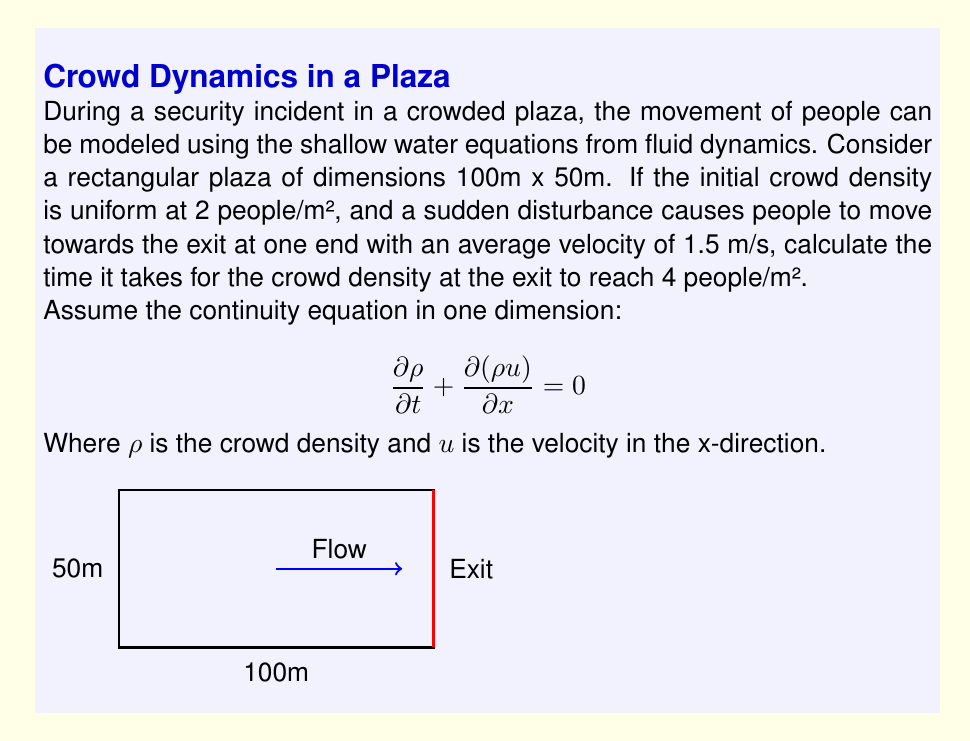Help me with this question. To solve this problem, we'll use the one-dimensional continuity equation and make some simplifying assumptions:

1) The flow is approximately one-dimensional towards the exit.
2) The velocity $u$ is constant at 1.5 m/s.
3) The change in density is linear along the length of the plaza.

Step 1: Set up the equation
$$\frac{\partial \rho}{\partial t} + \frac{\partial (\rho u)}{\partial x} = 0$$

Step 2: With constant velocity, we can simplify:
$$\frac{\partial \rho}{\partial t} + u\frac{\partial \rho}{\partial x} = 0$$

Step 3: Approximate the partial derivatives:
$$\frac{\Delta \rho}{\Delta t} + u\frac{\Delta \rho}{\Delta x} = 0$$

Step 4: Calculate $\Delta \rho$
Initial density: $\rho_i = 2$ people/m²
Final density at exit: $\rho_f = 4$ people/m²
$\Delta \rho = \rho_f - \rho_i = 2$ people/m²

Step 5: Calculate $\Delta x$
$\Delta x$ is the length of the plaza = 100 m

Step 6: Substitute into the equation
$$\frac{2}{\Delta t} + 1.5 \cdot \frac{2}{100} = 0$$

Step 7: Solve for $\Delta t$
$$\frac{2}{\Delta t} = -1.5 \cdot \frac{2}{100} = -0.03$$
$$\Delta t = \frac{2}{0.03} = 66.67 \text{ seconds}$$

Therefore, it takes approximately 66.67 seconds for the crowd density at the exit to reach 4 people/m².
Answer: 66.67 seconds 